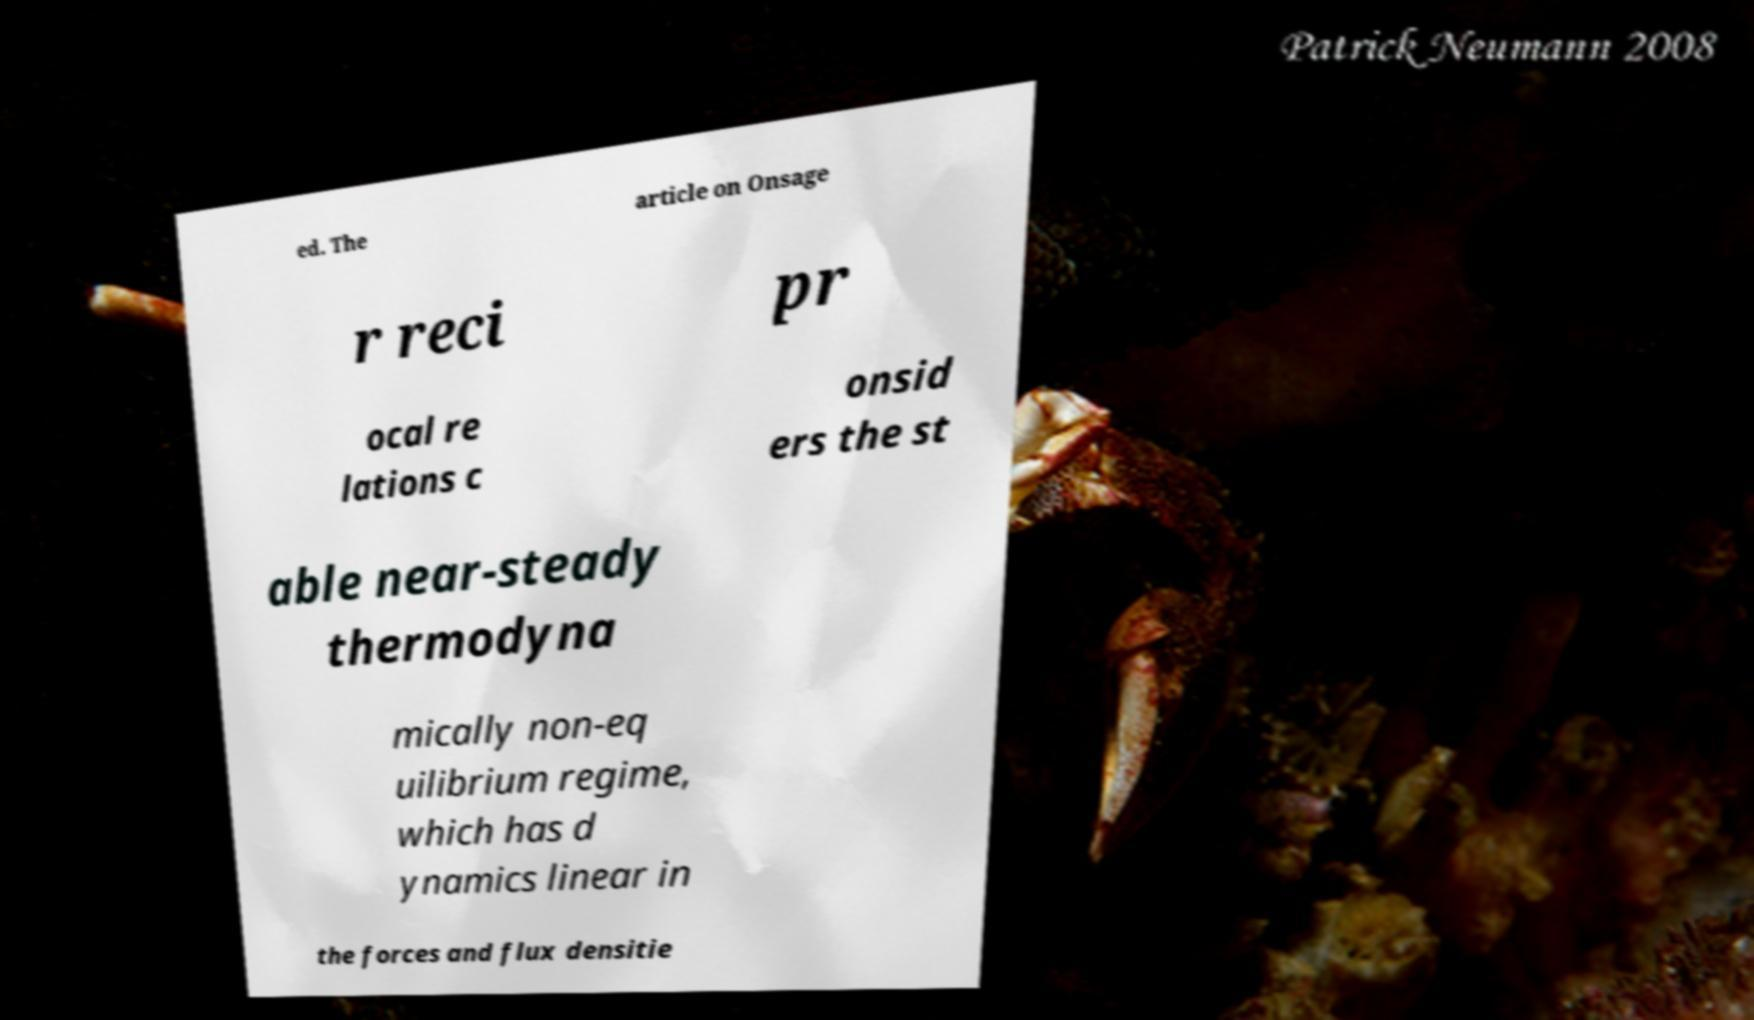Can you read and provide the text displayed in the image?This photo seems to have some interesting text. Can you extract and type it out for me? ed. The article on Onsage r reci pr ocal re lations c onsid ers the st able near-steady thermodyna mically non-eq uilibrium regime, which has d ynamics linear in the forces and flux densitie 